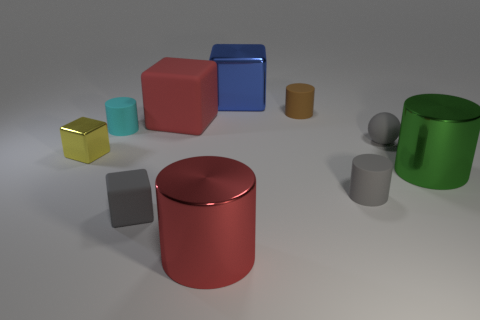There is a metallic cylinder left of the green metallic object; is its size the same as the blue thing?
Your answer should be very brief. Yes. What is the size of the other blue object that is the same shape as the small metallic object?
Provide a short and direct response. Large. There is a cyan object that is the same size as the gray rubber block; what is it made of?
Provide a succinct answer. Rubber. There is a gray thing that is the same shape as the tiny yellow thing; what material is it?
Your response must be concise. Rubber. How many other objects are the same size as the blue thing?
Give a very brief answer. 3. What size is the rubber cube that is the same color as the matte ball?
Provide a succinct answer. Small. How many tiny rubber things are the same color as the small ball?
Offer a very short reply. 2. What is the shape of the big matte thing?
Provide a succinct answer. Cube. The big metal thing that is in front of the tiny brown matte object and to the left of the small brown object is what color?
Offer a terse response. Red. What is the material of the ball?
Ensure brevity in your answer.  Rubber. 